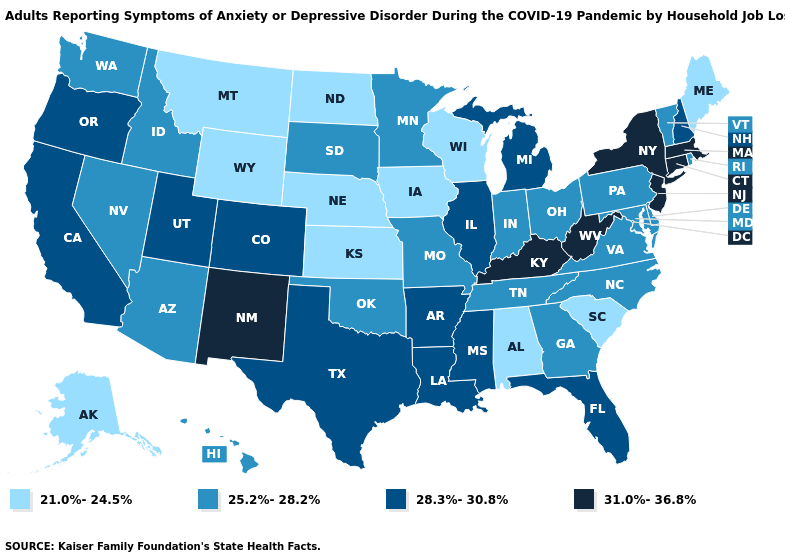What is the value of Louisiana?
Answer briefly. 28.3%-30.8%. Does the first symbol in the legend represent the smallest category?
Keep it brief. Yes. What is the value of Washington?
Short answer required. 25.2%-28.2%. Name the states that have a value in the range 25.2%-28.2%?
Short answer required. Arizona, Delaware, Georgia, Hawaii, Idaho, Indiana, Maryland, Minnesota, Missouri, Nevada, North Carolina, Ohio, Oklahoma, Pennsylvania, Rhode Island, South Dakota, Tennessee, Vermont, Virginia, Washington. What is the highest value in states that border Idaho?
Give a very brief answer. 28.3%-30.8%. What is the value of Michigan?
Keep it brief. 28.3%-30.8%. What is the value of Arizona?
Be succinct. 25.2%-28.2%. What is the value of California?
Answer briefly. 28.3%-30.8%. Does Connecticut have the same value as Colorado?
Be succinct. No. Among the states that border West Virginia , which have the lowest value?
Keep it brief. Maryland, Ohio, Pennsylvania, Virginia. What is the lowest value in states that border Kentucky?
Give a very brief answer. 25.2%-28.2%. How many symbols are there in the legend?
Be succinct. 4. Which states have the lowest value in the MidWest?
Short answer required. Iowa, Kansas, Nebraska, North Dakota, Wisconsin. What is the highest value in the Northeast ?
Be succinct. 31.0%-36.8%. What is the value of New York?
Quick response, please. 31.0%-36.8%. 